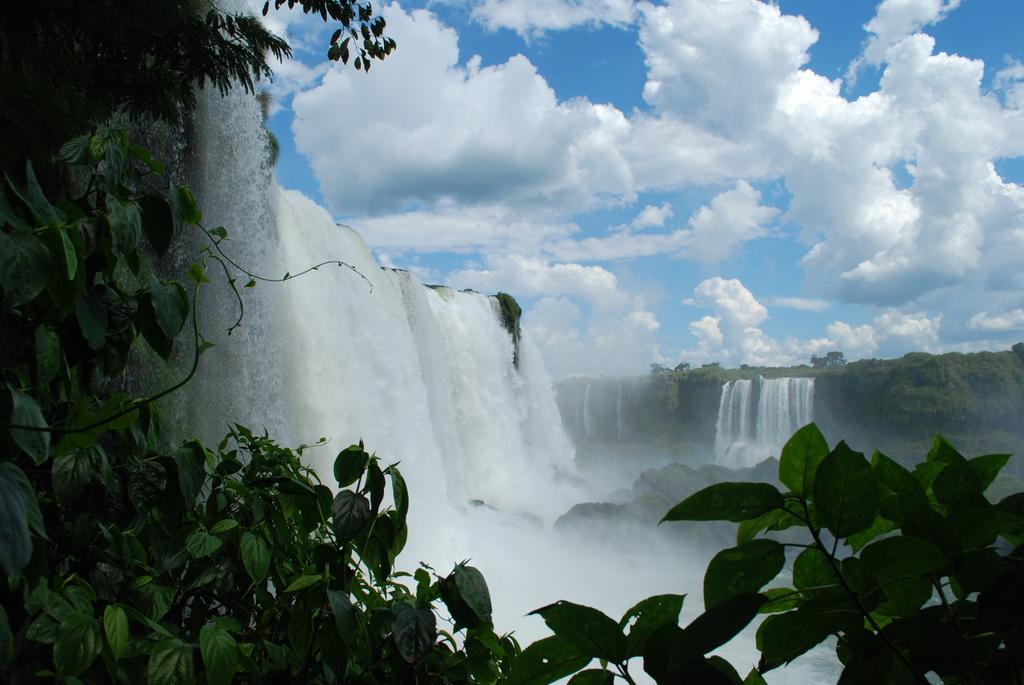Could you give a brief overview of what you see in this image? In the foreground of the picture I can see the green leaves. In the background, I can see the waterfalls and trees. There are clouds in the sky. 